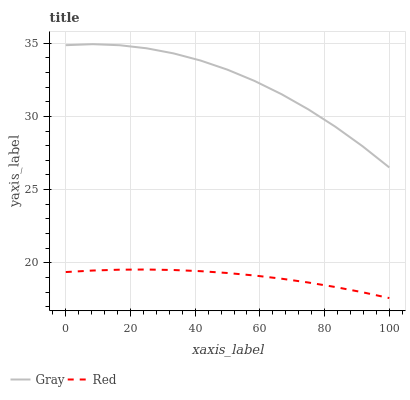Does Red have the minimum area under the curve?
Answer yes or no. Yes. Does Gray have the maximum area under the curve?
Answer yes or no. Yes. Does Red have the maximum area under the curve?
Answer yes or no. No. Is Red the smoothest?
Answer yes or no. Yes. Is Gray the roughest?
Answer yes or no. Yes. Is Red the roughest?
Answer yes or no. No. Does Red have the lowest value?
Answer yes or no. Yes. Does Gray have the highest value?
Answer yes or no. Yes. Does Red have the highest value?
Answer yes or no. No. Is Red less than Gray?
Answer yes or no. Yes. Is Gray greater than Red?
Answer yes or no. Yes. Does Red intersect Gray?
Answer yes or no. No. 